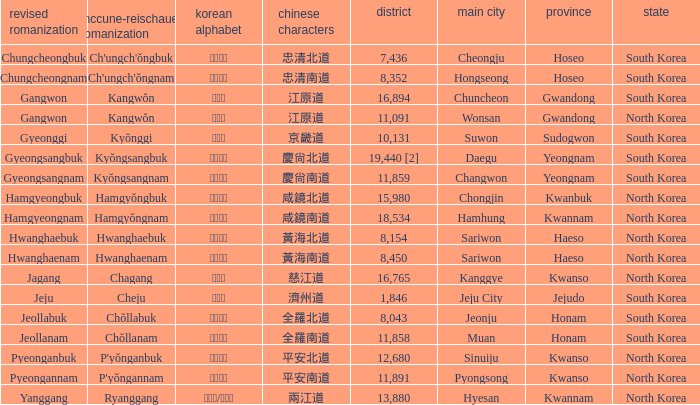What is the RR Romaja for the province that has Hangul of 강원도 and capital of Wonsan? Gangwon. 